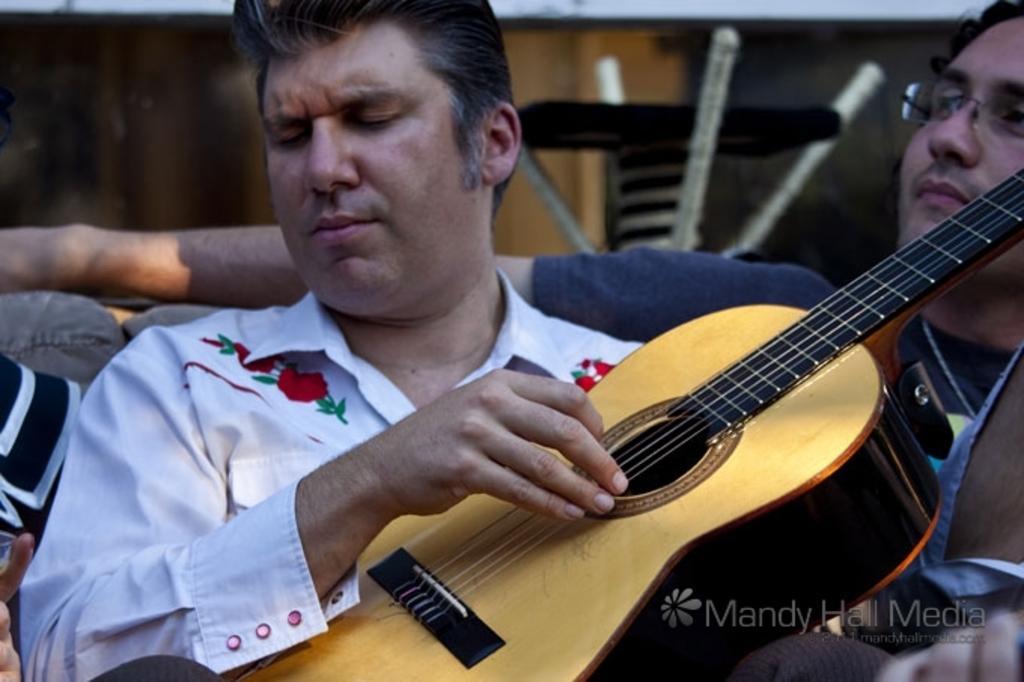Please provide a concise description of this image. This picture shows a man holding a guitar in his hands and playing it. Beside him there is another man, wearing spectacles. In the background there is a wall. 